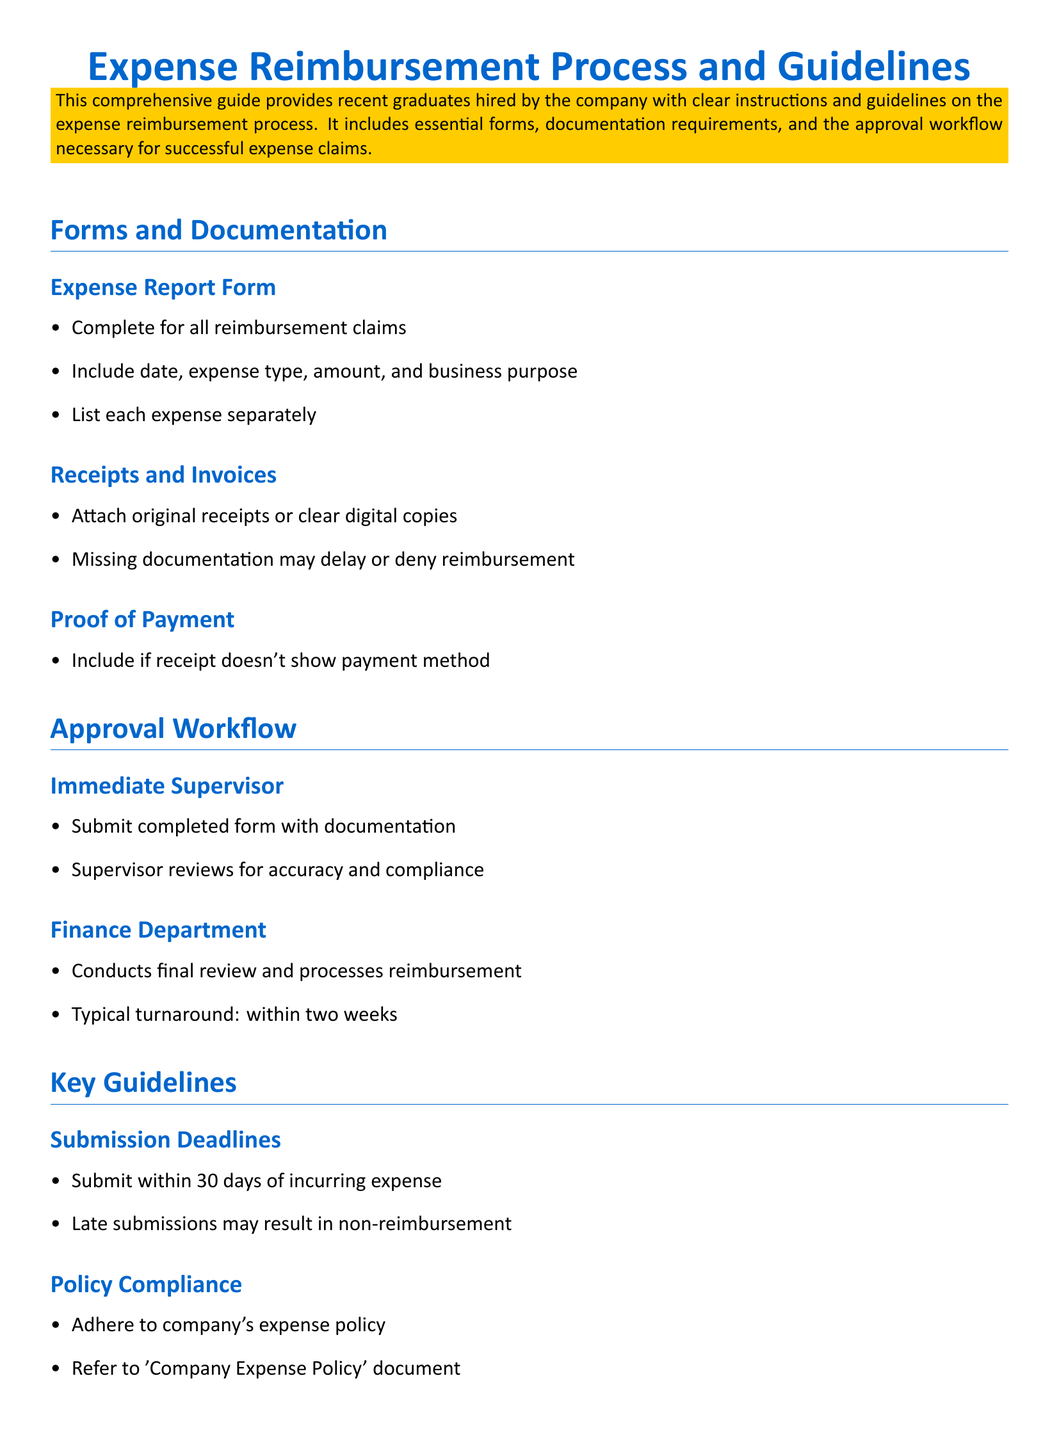what is the title of the document? The title is prominently displayed at the top of the document, indicating its purpose.
Answer: Expense Reimbursement Process and Guidelines what is the color of the main title? The main title is presented in a specific color that stands out.
Answer: RGB(0,102,204) how long does the finance department take to process reimbursements? The document specifies a typical timeframe for reimbursement processing.
Answer: within two weeks what should be included in the expense report form? The document lists required details that must be filled out in this form.
Answer: date, expense type, amount, and business purpose how many days do you have to submit an expense after incurring it? The guidelines state a specific duration for submission after the expense is incurred.
Answer: 30 days what happens if submissions are late? The guidelines convey a consequence related to submission timelines.
Answer: non-reimbursement which department conducts the final review of the expense reports? The document indicates which department is responsible for the final approval process.
Answer: Finance Department what type of documentation must be attached to the reimbursement claims? The document describes specific paperwork that must accompany claims.
Answer: original receipts or clear digital copies how long should you maintain records of expense reports? The guidelines mention a recommended duration for record retention.
Answer: up to one year 